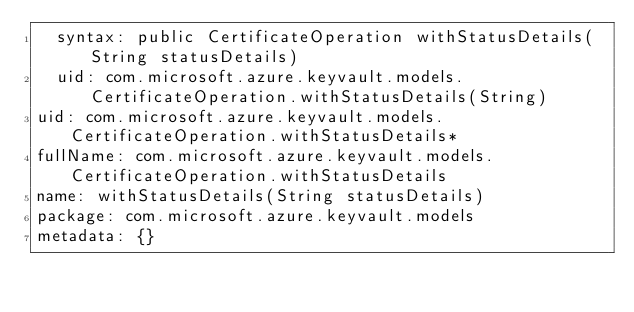<code> <loc_0><loc_0><loc_500><loc_500><_YAML_>  syntax: public CertificateOperation withStatusDetails(String statusDetails)
  uid: com.microsoft.azure.keyvault.models.CertificateOperation.withStatusDetails(String)
uid: com.microsoft.azure.keyvault.models.CertificateOperation.withStatusDetails*
fullName: com.microsoft.azure.keyvault.models.CertificateOperation.withStatusDetails
name: withStatusDetails(String statusDetails)
package: com.microsoft.azure.keyvault.models
metadata: {}
</code> 